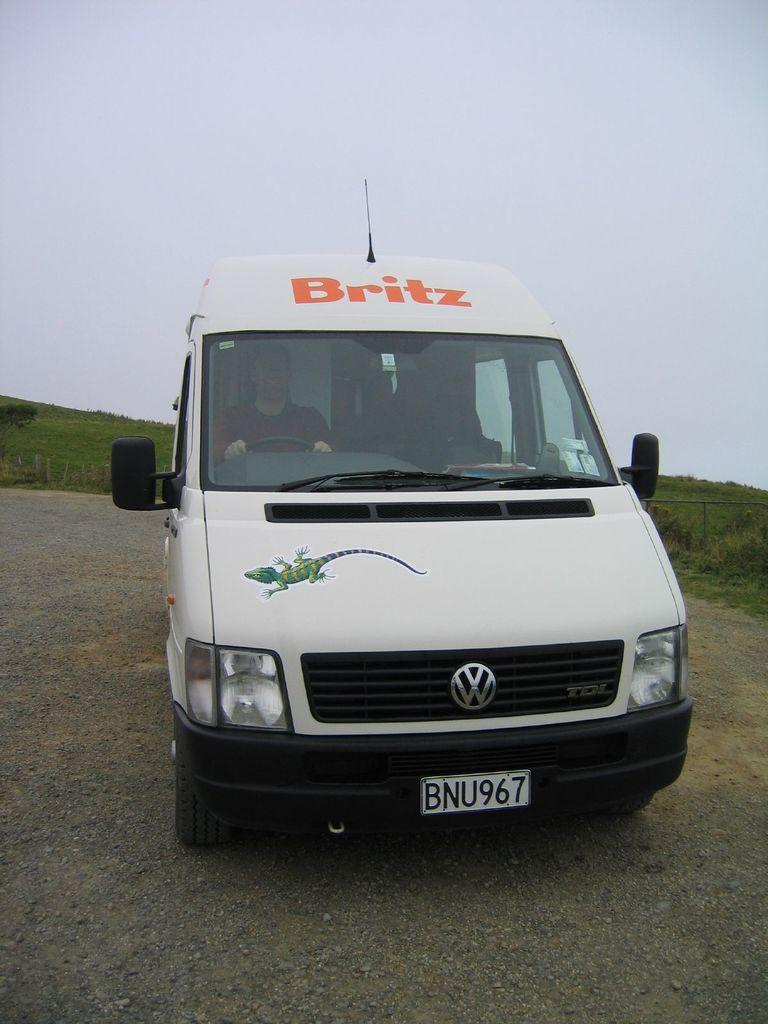What is the main subject in the center of the image? There is a vehicle in the center of the image. Who is inside the vehicle? A person is sitting in the vehicle. What is at the bottom of the image? There is a road at the bottom of the image. What can be seen in the background of the image? There is grass and the sky visible in the background of the image. What type of riddle is the vehicle trying to solve in the image? There is no riddle present in the image; it is a vehicle with a person sitting inside. What liquid can be seen flowing through the vehicle in the image? There is no liquid flowing through the vehicle in the image; it is a vehicle with a person sitting inside. 